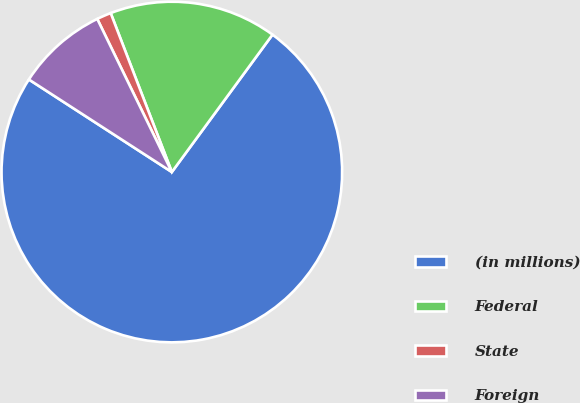Convert chart to OTSL. <chart><loc_0><loc_0><loc_500><loc_500><pie_chart><fcel>(in millions)<fcel>Federal<fcel>State<fcel>Foreign<nl><fcel>74.08%<fcel>15.91%<fcel>1.37%<fcel>8.64%<nl></chart> 